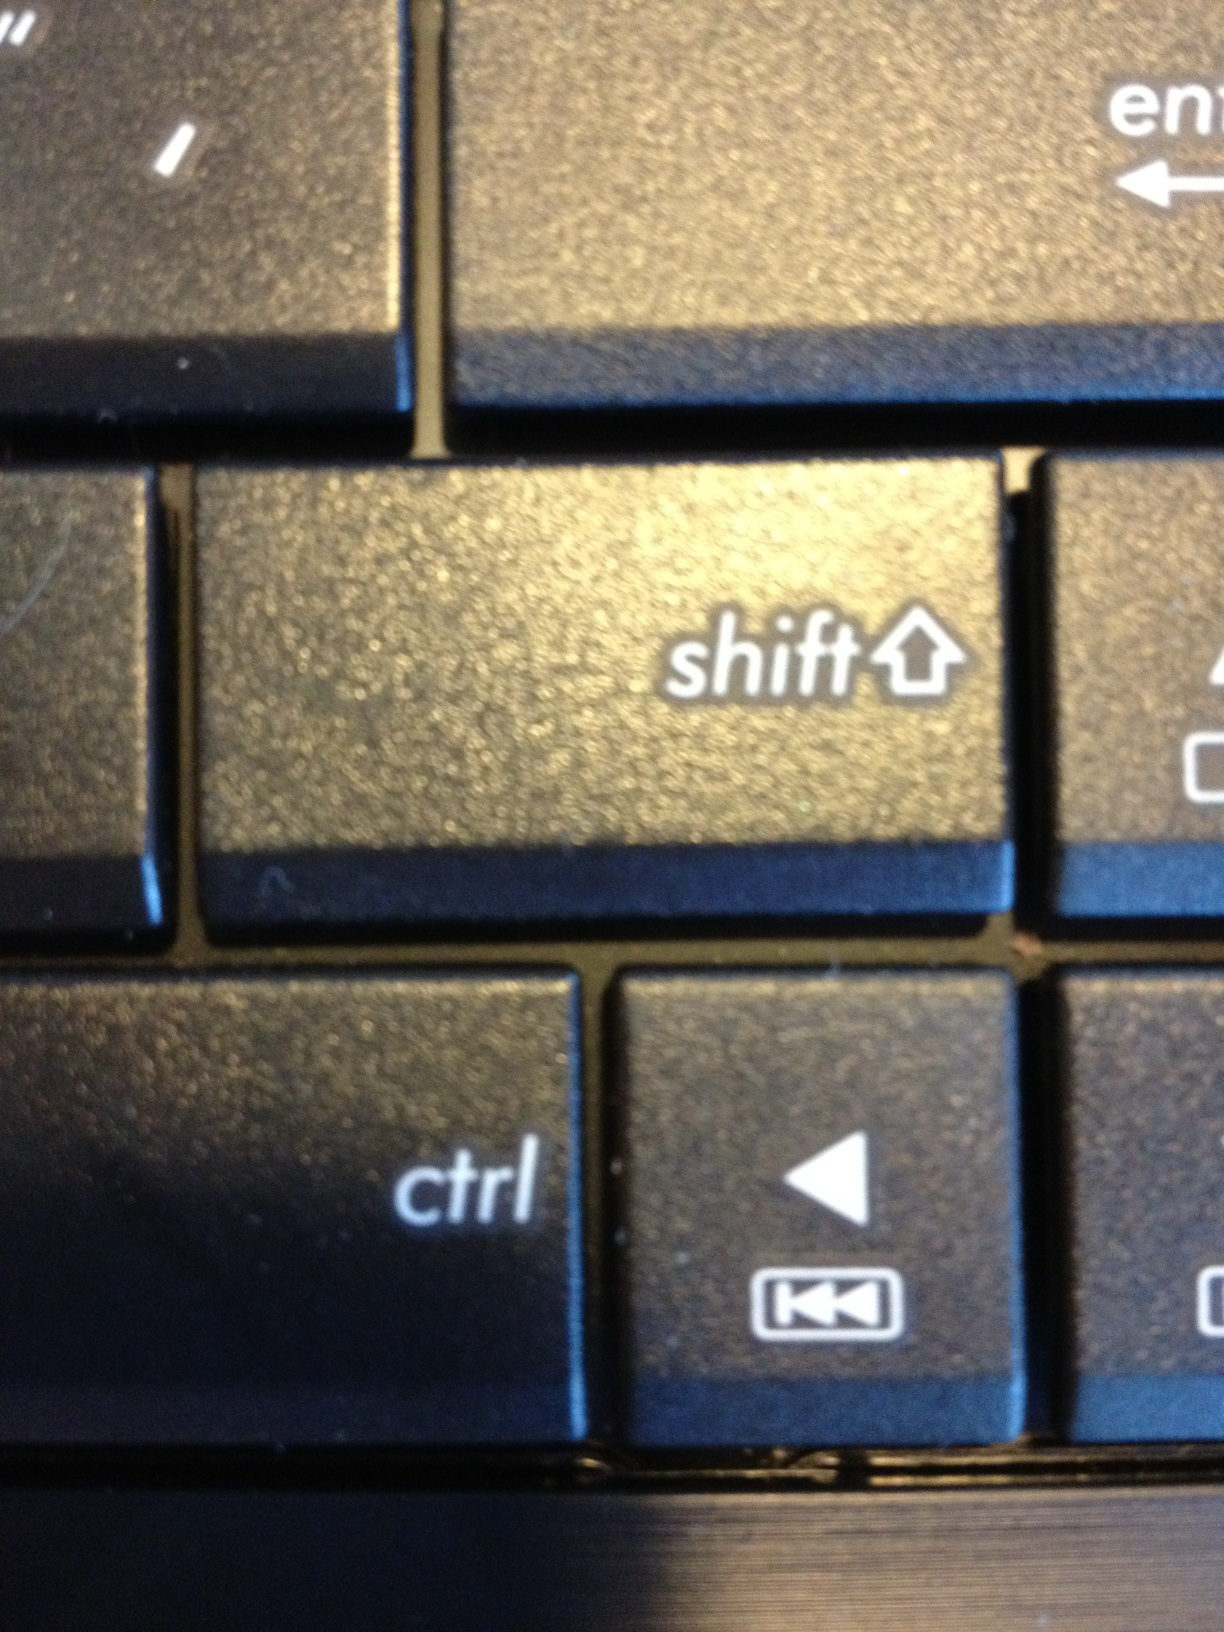Can you tell me what the condition of the keyboard is? The keys on the keyboard appear well-used with slight shining on the surfaces that indicate wear from frequent use. The visible edges and ridges of the keys have collected some dust and debris, suggesting that the keyboard may not have been cleaned recently. 